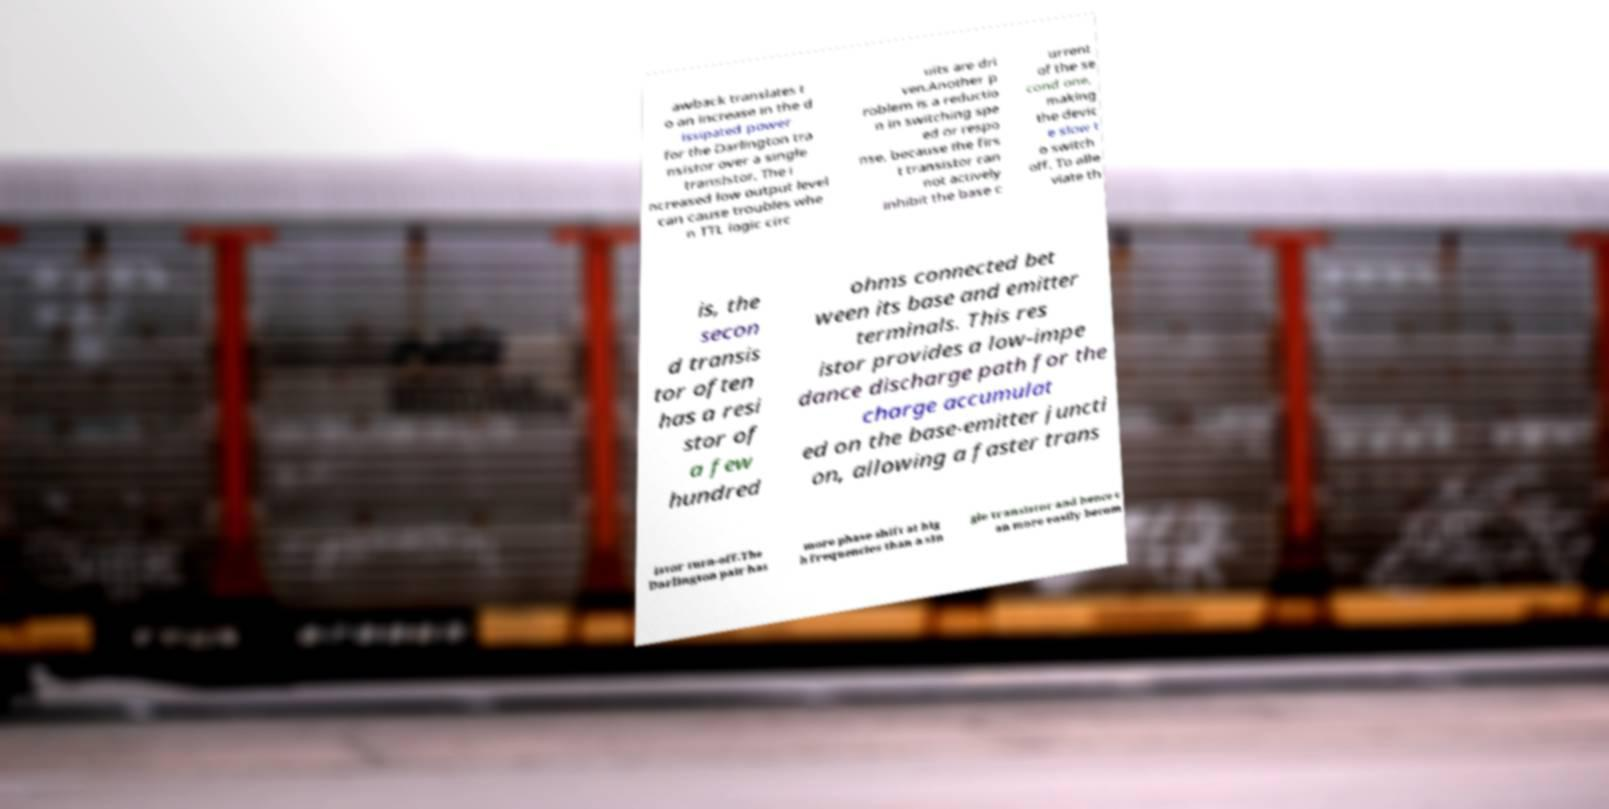What messages or text are displayed in this image? I need them in a readable, typed format. awback translates t o an increase in the d issipated power for the Darlington tra nsistor over a single transistor. The i ncreased low output level can cause troubles whe n TTL logic circ uits are dri ven.Another p roblem is a reductio n in switching spe ed or respo nse, because the firs t transistor can not actively inhibit the base c urrent of the se cond one, making the devic e slow t o switch off. To alle viate th is, the secon d transis tor often has a resi stor of a few hundred ohms connected bet ween its base and emitter terminals. This res istor provides a low-impe dance discharge path for the charge accumulat ed on the base-emitter juncti on, allowing a faster trans istor turn-off.The Darlington pair has more phase shift at hig h frequencies than a sin gle transistor and hence c an more easily becom 